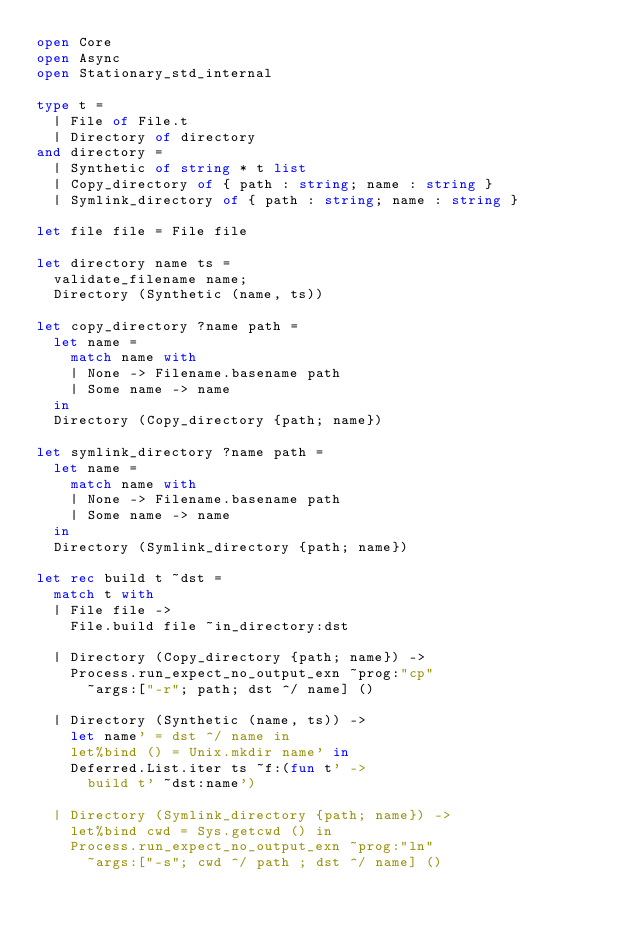Convert code to text. <code><loc_0><loc_0><loc_500><loc_500><_OCaml_>open Core
open Async
open Stationary_std_internal

type t =
  | File of File.t
  | Directory of directory
and directory =
  | Synthetic of string * t list
  | Copy_directory of { path : string; name : string }
  | Symlink_directory of { path : string; name : string }

let file file = File file

let directory name ts =
  validate_filename name;
  Directory (Synthetic (name, ts))

let copy_directory ?name path =
  let name =
    match name with
    | None -> Filename.basename path
    | Some name -> name
  in
  Directory (Copy_directory {path; name})

let symlink_directory ?name path =
  let name =
    match name with
    | None -> Filename.basename path
    | Some name -> name
  in
  Directory (Symlink_directory {path; name})

let rec build t ~dst =
  match t with
  | File file ->
    File.build file ~in_directory:dst

  | Directory (Copy_directory {path; name}) ->
    Process.run_expect_no_output_exn ~prog:"cp"
      ~args:["-r"; path; dst ^/ name] ()

  | Directory (Synthetic (name, ts)) ->
    let name' = dst ^/ name in
    let%bind () = Unix.mkdir name' in
    Deferred.List.iter ts ~f:(fun t' ->
      build t' ~dst:name')

  | Directory (Symlink_directory {path; name}) ->
    let%bind cwd = Sys.getcwd () in
    Process.run_expect_no_output_exn ~prog:"ln"
      ~args:["-s"; cwd ^/ path ; dst ^/ name] ()
</code> 